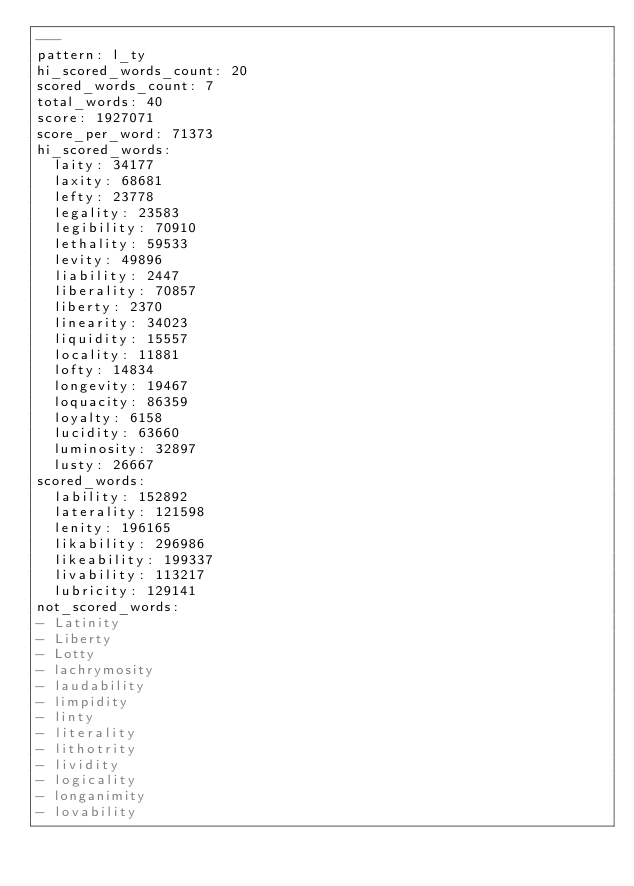<code> <loc_0><loc_0><loc_500><loc_500><_YAML_>---
pattern: l_ty
hi_scored_words_count: 20
scored_words_count: 7
total_words: 40
score: 1927071
score_per_word: 71373
hi_scored_words:
  laity: 34177
  laxity: 68681
  lefty: 23778
  legality: 23583
  legibility: 70910
  lethality: 59533
  levity: 49896
  liability: 2447
  liberality: 70857
  liberty: 2370
  linearity: 34023
  liquidity: 15557
  locality: 11881
  lofty: 14834
  longevity: 19467
  loquacity: 86359
  loyalty: 6158
  lucidity: 63660
  luminosity: 32897
  lusty: 26667
scored_words:
  lability: 152892
  laterality: 121598
  lenity: 196165
  likability: 296986
  likeability: 199337
  livability: 113217
  lubricity: 129141
not_scored_words:
- Latinity
- Liberty
- Lotty
- lachrymosity
- laudability
- limpidity
- linty
- literality
- lithotrity
- lividity
- logicality
- longanimity
- lovability
</code> 